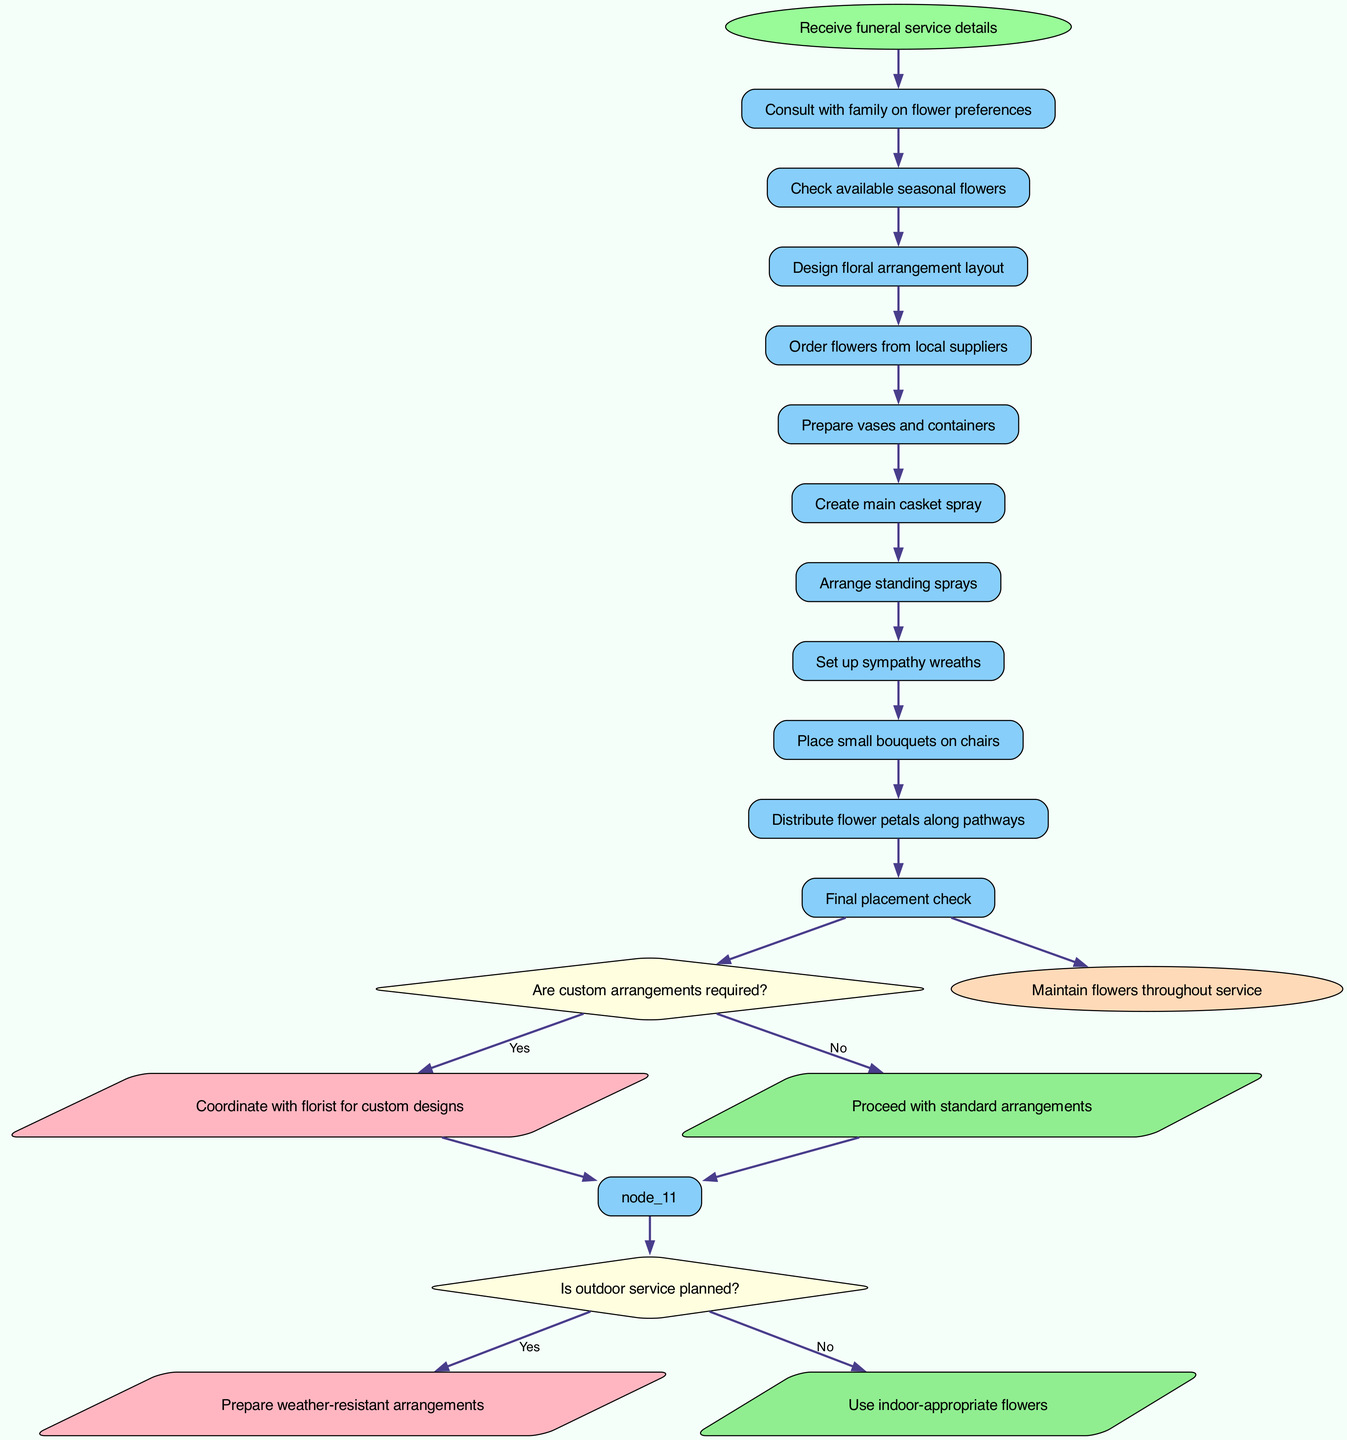What is the starting point of the workflow? The starting point of the workflow is the node labeled "Receive funeral service details," indicating the initiation of the entire process.
Answer: Receive funeral service details How many nodes are there in the diagram? By counting all the individual nodes that represent steps in the process, we find that there are a total of 11 nodes, including the start and end nodes.
Answer: 11 What is the final step in the flowchart? The final step in the flowchart is represented by the node labeled "Maintain flowers throughout service," which indicates the conclusion of the arrangement workflow.
Answer: Maintain flowers throughout service What happens if custom arrangements are not required? If custom arrangements are not required, the workflow proceeds to create standard arrangements, leading to the design of floral layout immediately after consulting with the family.
Answer: Proceed with standard arrangements What do you do if an outdoor service is planned? If an outdoor service is planned, the workflow directs to prepare weather-resistant arrangements to ensure the flowers endure outdoor conditions.
Answer: Prepare weather-resistant arrangements How many decision points are indicated in the flowchart? The diagram indicates two decision points, which assess whether custom arrangements are needed and if an outdoor service is planned.
Answer: 2 What is the shape of decision nodes in the diagram? The decision nodes are represented in a diamond shape, which is standard for illustrating decision-making points in flowcharts.
Answer: Diamond What node follows the "Create main casket spray"? Following the "Create main casket spray," the next node in the flow is "Arrange standing sprays," indicating the sequence of tasks.
Answer: Arrange standing sprays What type of arrangement is prepared if the service is not outdoors? If the service is not outdoors, the workflow calls for the use of indoor-appropriate flowers, ensuring that arrangements fit the service environment.
Answer: Use indoor-appropriate flowers 